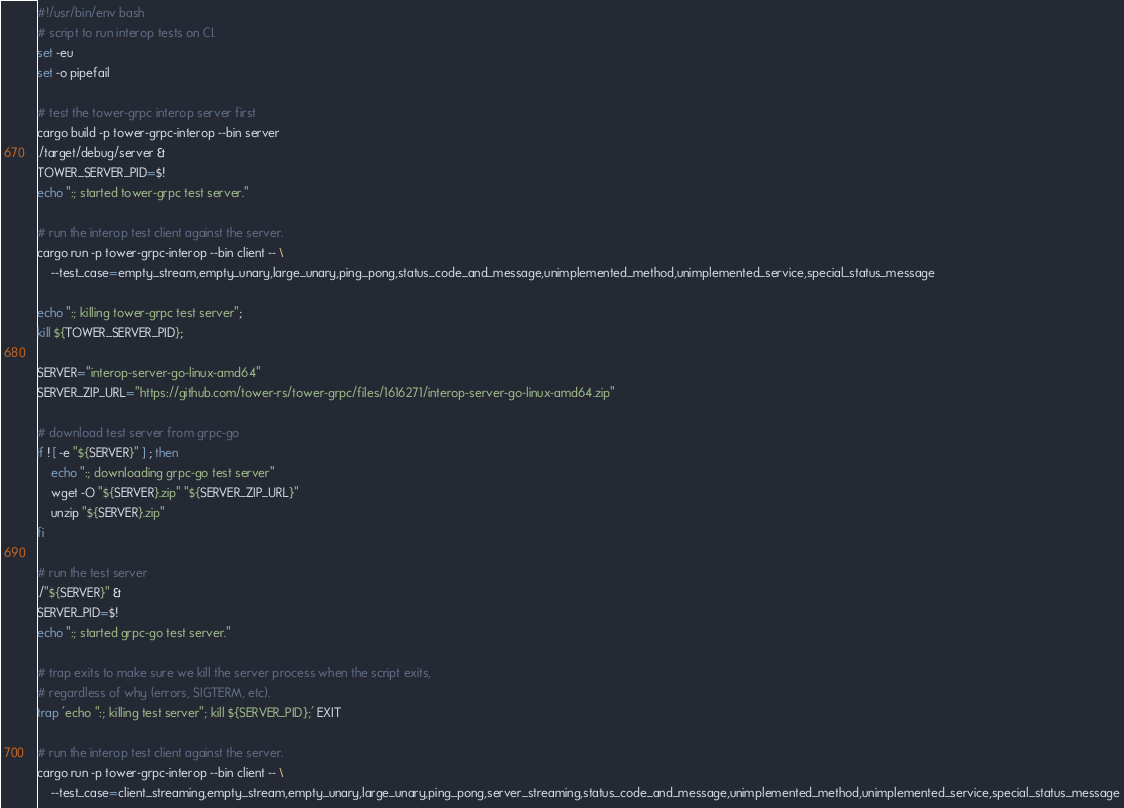Convert code to text. <code><loc_0><loc_0><loc_500><loc_500><_Bash_>#!/usr/bin/env bash
# script to run interop tests on CI.
set -eu
set -o pipefail

# test the tower-grpc interop server first
cargo build -p tower-grpc-interop --bin server
./target/debug/server &
TOWER_SERVER_PID=$!
echo ":; started tower-grpc test server."

# run the interop test client against the server.
cargo run -p tower-grpc-interop --bin client -- \
    --test_case=empty_stream,empty_unary,large_unary,ping_pong,status_code_and_message,unimplemented_method,unimplemented_service,special_status_message

echo ":; killing tower-grpc test server";
kill ${TOWER_SERVER_PID};

SERVER="interop-server-go-linux-amd64"
SERVER_ZIP_URL="https://github.com/tower-rs/tower-grpc/files/1616271/interop-server-go-linux-amd64.zip"

# download test server from grpc-go
if ! [ -e "${SERVER}" ] ; then
    echo ":; downloading grpc-go test server"
    wget -O "${SERVER}.zip" "${SERVER_ZIP_URL}"
    unzip "${SERVER}.zip"
fi

# run the test server
./"${SERVER}" &
SERVER_PID=$!
echo ":; started grpc-go test server."

# trap exits to make sure we kill the server process when the script exits,
# regardless of why (errors, SIGTERM, etc).
trap 'echo ":; killing test server"; kill ${SERVER_PID};' EXIT

# run the interop test client against the server.
cargo run -p tower-grpc-interop --bin client -- \
    --test_case=client_streaming,empty_stream,empty_unary,large_unary,ping_pong,server_streaming,status_code_and_message,unimplemented_method,unimplemented_service,special_status_message
</code> 